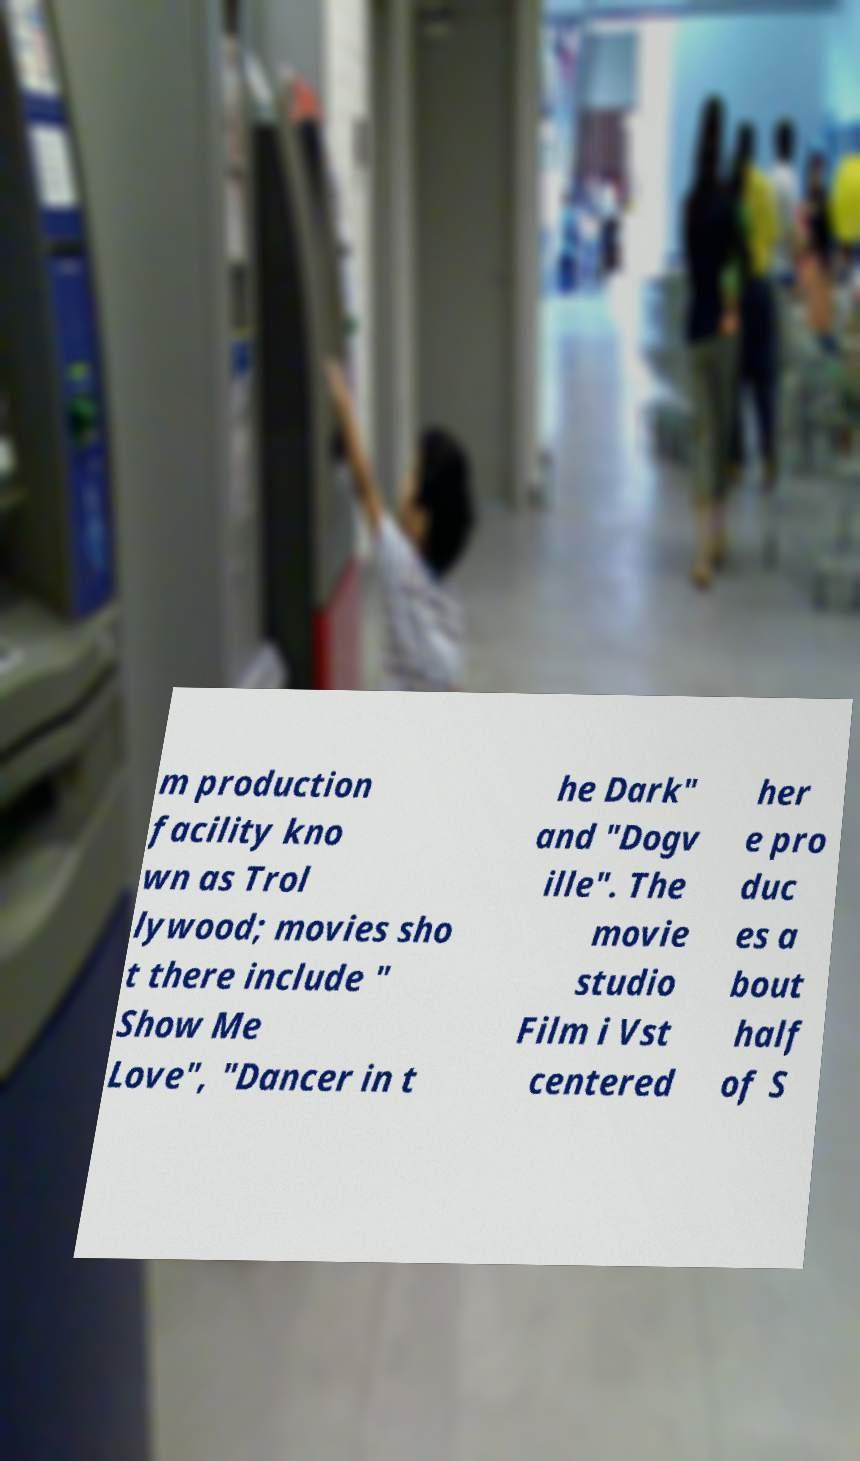Can you accurately transcribe the text from the provided image for me? m production facility kno wn as Trol lywood; movies sho t there include " Show Me Love", "Dancer in t he Dark" and "Dogv ille". The movie studio Film i Vst centered her e pro duc es a bout half of S 